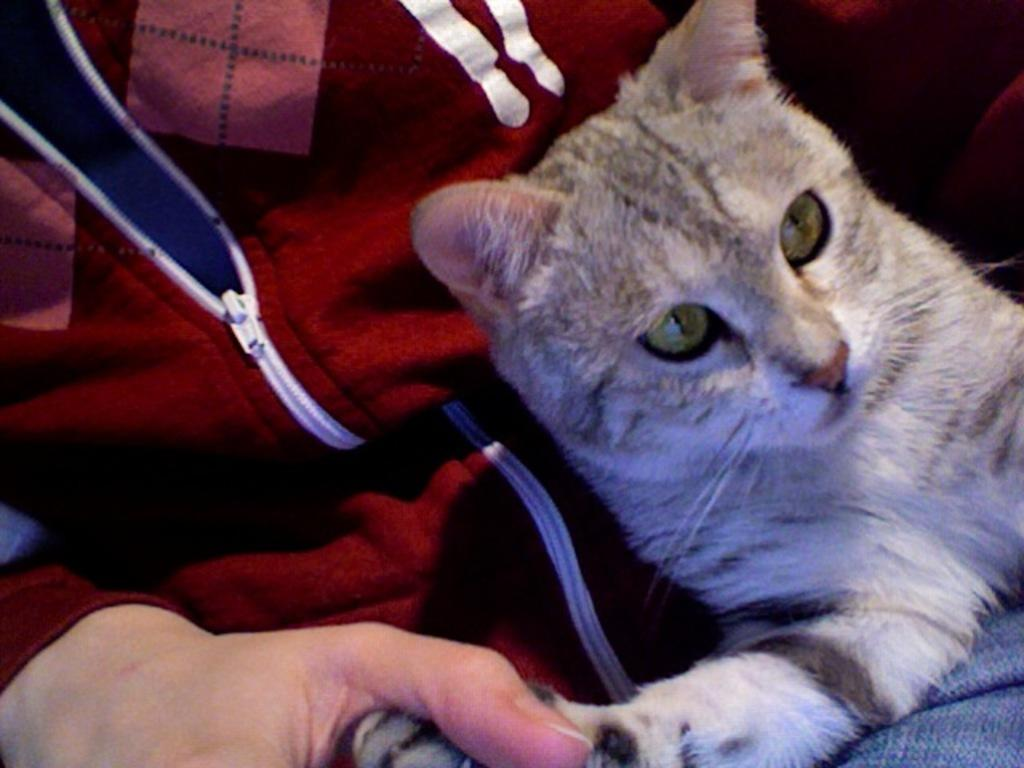What is located on the left side of the image? There is a person on the left side of the image. What is the person wearing? The person is wearing a red jacket. What is the person doing in the image? The person is sitting. What can be seen on the right side of the image? There is a cat on the right side of the image. How many steps does the grandmother take in the image? There is no grandmother present in the image, and therefore no steps can be counted. What type of bun is the person holding in the image? There is no bun present in the image; the person is wearing a red jacket and sitting. 